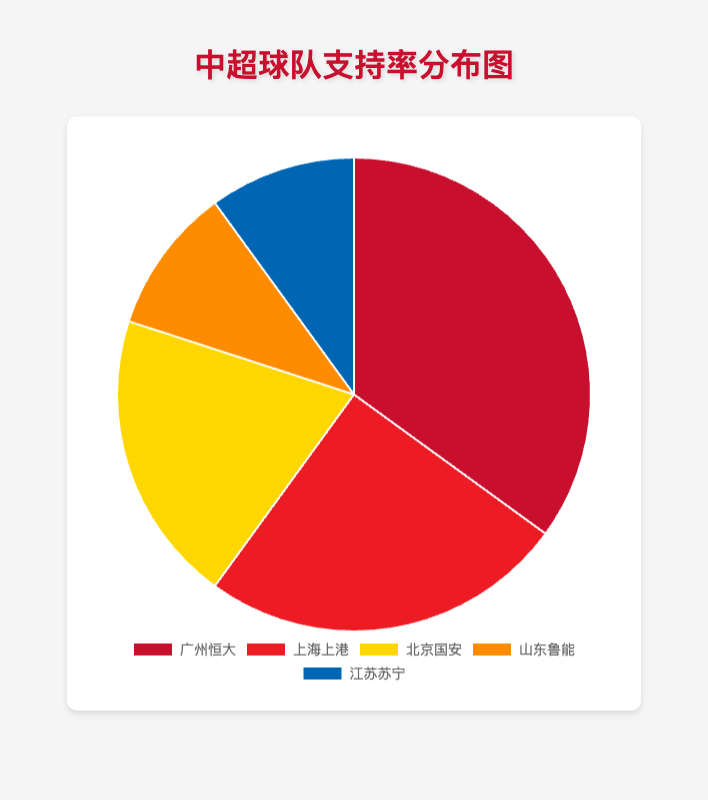Which CSL team has the highest proportion of fans? Look at the figure to identify the segment with the largest proportion. Guangzhou Evergrande occupies the largest slice.
Answer: Guangzhou Evergrande How many percentage points are there between the team with the most fans and the team with the least fans? Determine the difference between Guangzhou Evergrande (35%) and Shandong Luneng/Jiangsu Suning (both 10%). 35 - 10 = 25
Answer: 25 What is the total combined proportion of fans for Beijing Guoan and Shandong Luneng? Add the proportions for Beijing Guoan (20%) and Shandong Luneng (10%). 20 + 10 = 30
Answer: 30 Which team has a higher proportion of fans, Shanghai SIPG or Beijing Guoan? Compare the slices for Shanghai SIPG (25%) and Beijing Guoan (20%). 25 > 20
Answer: Shanghai SIPG What colors are used for Guangzhou Evergrande and Jiangsu Suning in the pie chart? Identify the segments with colors corresponding to the labels for Guangzhou Evergrande and Jiangsu Suning. Guangzhou Evergrande is shown in red, and Jiangsu Suning in blue.
Answer: Red and Blue What is the difference in the proportion of fans between Shanghai SIPG and Shandong Luneng? Determine the difference between Shanghai SIPG (25%) and Shandong Luneng (10%). 25 - 10 = 15
Answer: 15 Do Beijing Guoan and Jiangsu Suning together have more fans than Guangzhou Evergrande? Add the proportions for Beijing Guoan (20%) and Jiangsu Suning (10%) and compare to Guangzhou Evergrande (35%). 20 + 10 = 30, which is less than 35.
Answer: No How does the proportion of fans for Shandong Luneng compare to Jiangsu Suning? Compare the proportions directly (both are 10%).
Answer: Equal What percentage of fans follow either Guangzhou Evergrande or Shanghai SIPG? Add their proportions. Guangzhou Evergrande (35%) and Shanghai SIPG (25%). 35 + 25 = 60
Answer: 60 Which team occupies the smallest slice in the pie chart and what is the color of this slice? Identify the smallest slices, for Shandong Luneng and Jiangsu Suning, both taking 10%. They are respectively in orange and blue.
Answer: Jiangsu Suning and Shandong Luneng, Blue and Orange 